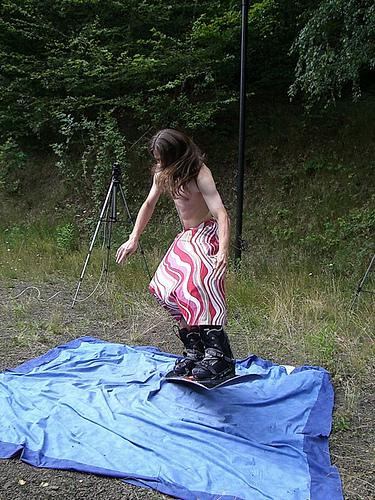Briefly summarize the contents of the image. Shirtless man snowboarding on blue mat with striped skirt and black boots; camera tripod and black pole also present. From the perspective of the man in the image, what is he doing? I'm a shirtless man with long hair riding a snowboard on a blue mat, wearing a striped skirt and black boots, as a camera tripod captures the moment. Describe the appearance and actions of the main subject in the present tense. A man with long hair, no shirt, and a striped skirt stands confidently on a snowboard with black boots, as he glides over a blue mat with a camera tripod nearby. Highlight the atypical or unusual aspects of the image. An intriguing feature is that the shirtless man is riding a snowboard while sporting a vibrant striped skirt amid green foliage with a camera tripod capturing the moment nearby. What is the central figure in the image doing and what are they wearing? A shirtless man with long hair is riding a snowboard on a blue mat wearing a colorful striped skirt and black snowboard boots. Using expressive language, convey the atmosphere of the scene. Amidst a backdrop of leafy green trees, a daring shirtless man showcases his prowess by balancing skillfully atop a snowboard on a vivid blue tarp. How would you describe the image to someone who can't see it? The image shows a man without a shirt, long hair, and a striped skirt, as he's snowboarding on a blue blanket with his snowboard boots, in the company of a camera tripod on grassy terrain. Mention any equipment or objects featured prominently alongside the main subject in the image. A camera tripod is positioned on the grass to the left of a man riding a snowboard, and there is a long black pole extending from the ground. Describe the image as if you were telling the story to a child. Once upon a time, a brave shirtless man with long hair decided to ride his snowboard on a blue blanket, wearing a funny-looking striped skirt and black boots, with his trusty camera tripod nearby. Detail the variety of elements found in the image. Elements of the image include a shirtless man with long hair, snowboarding on a blue mat, wearing a striped skirt and black boots with buckles, surrounded by green trees, a camera tripod, and a black pole. 